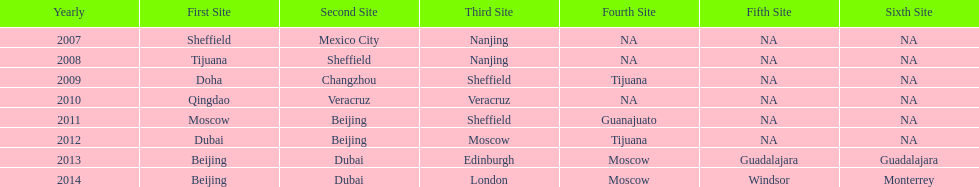When was the final year that tijuana functioned as a venue? 2012. 